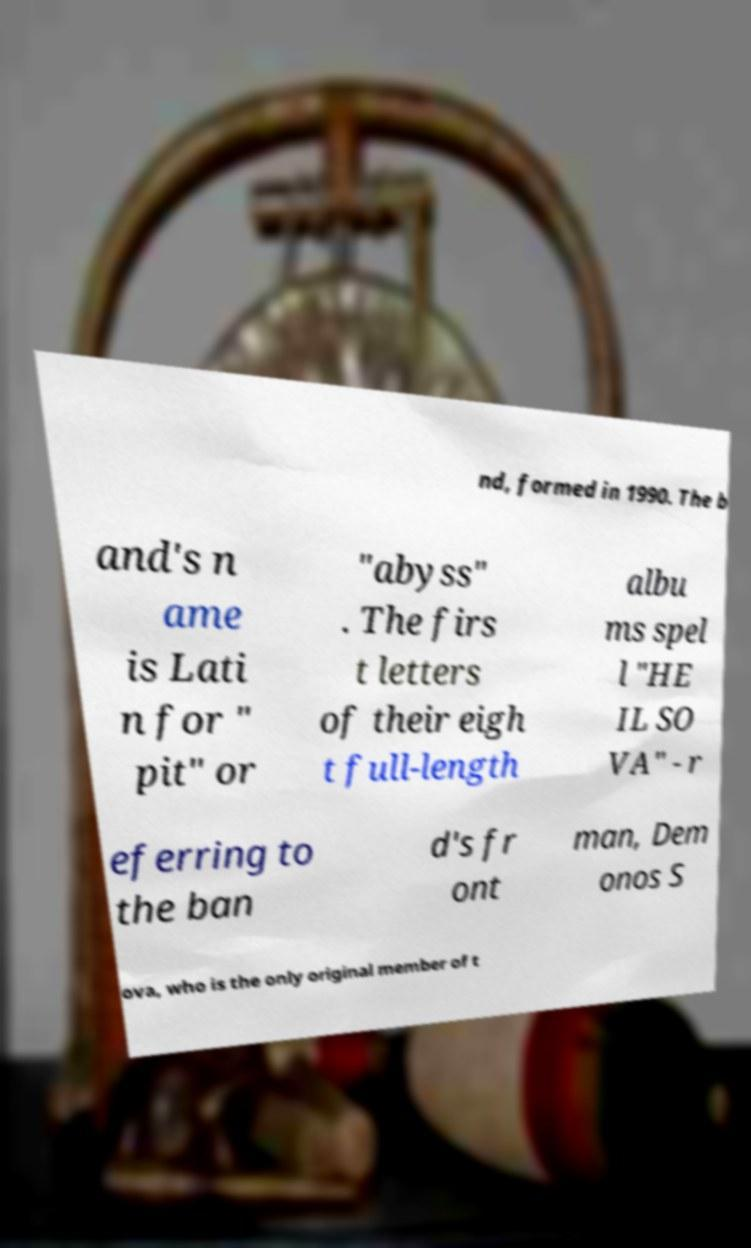Can you accurately transcribe the text from the provided image for me? nd, formed in 1990. The b and's n ame is Lati n for " pit" or "abyss" . The firs t letters of their eigh t full-length albu ms spel l "HE IL SO VA" - r eferring to the ban d's fr ont man, Dem onos S ova, who is the only original member of t 